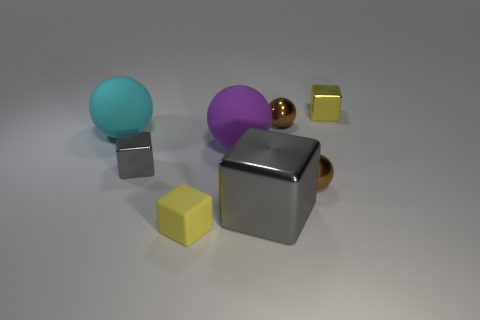Are there more brown metallic balls that are in front of the tiny gray metal thing than big yellow matte cubes?
Keep it short and to the point. Yes. What number of other objects are the same shape as the tiny gray metallic object?
Keep it short and to the point. 3. There is a small cube that is both to the left of the big gray metal object and behind the tiny yellow matte thing; what material is it?
Provide a short and direct response. Metal. What number of objects are cubes or metallic things?
Ensure brevity in your answer.  6. Are there more purple metal blocks than cyan balls?
Your answer should be very brief. No. How big is the yellow thing that is behind the large thing that is in front of the purple matte ball?
Keep it short and to the point. Small. There is a big metal object that is the same shape as the small yellow rubber thing; what is its color?
Your answer should be compact. Gray. The cyan sphere is what size?
Ensure brevity in your answer.  Large. How many cylinders are big matte things or metal things?
Provide a short and direct response. 0. What size is the cyan thing that is the same shape as the purple thing?
Offer a terse response. Large. 